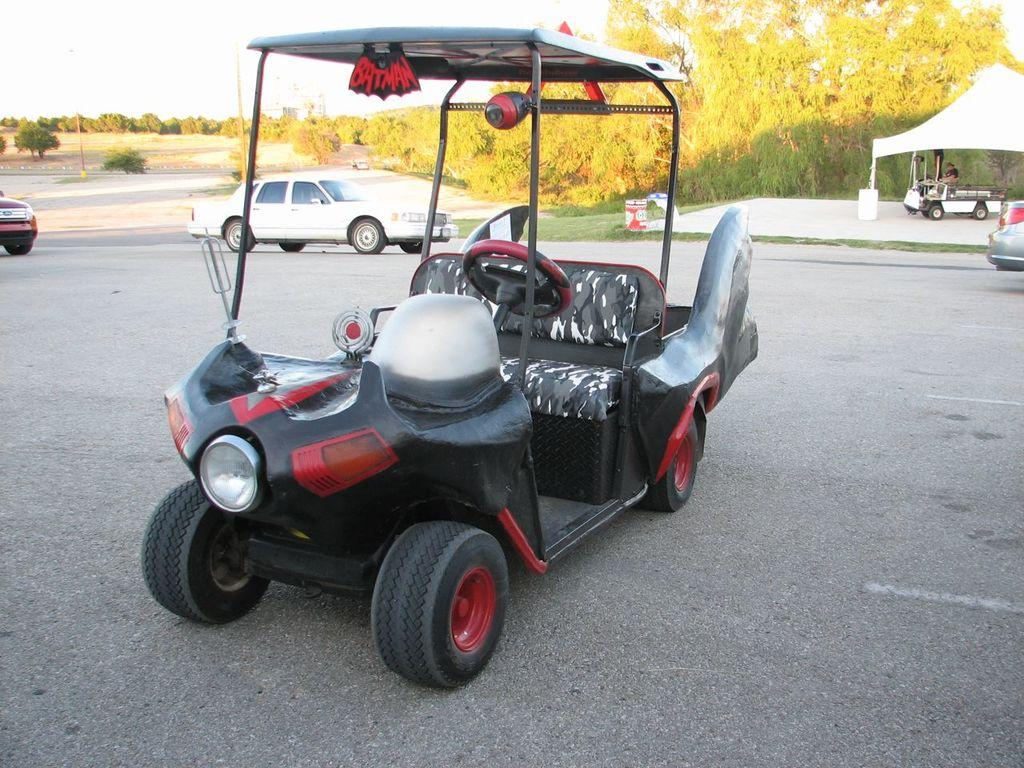What types of objects are present in the image? There are vehicles in the image. What can be seen in the background of the image? There are trees and poles in the background of the image. What structure is located on the right side of the image? There is a shed on the right side of the image. Where is the kettle located in the image? There is no kettle present in the image. What is the secretary's role in the image? There is no secretary present in the image. 